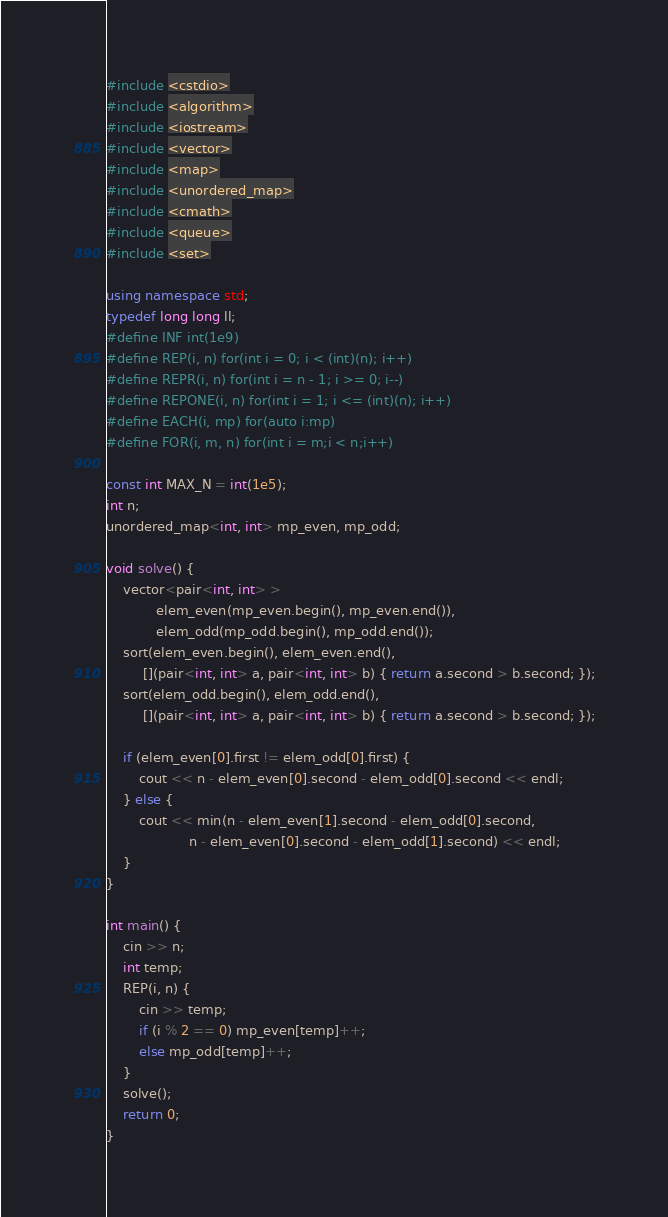<code> <loc_0><loc_0><loc_500><loc_500><_C++_>#include <cstdio>
#include <algorithm>
#include <iostream>
#include <vector>
#include <map>
#include <unordered_map>
#include <cmath>
#include <queue>
#include <set>

using namespace std;
typedef long long ll;
#define INF int(1e9)
#define REP(i, n) for(int i = 0; i < (int)(n); i++)
#define REPR(i, n) for(int i = n - 1; i >= 0; i--)
#define REPONE(i, n) for(int i = 1; i <= (int)(n); i++)
#define EACH(i, mp) for(auto i:mp)
#define FOR(i, m, n) for(int i = m;i < n;i++)

const int MAX_N = int(1e5);
int n;
unordered_map<int, int> mp_even, mp_odd;

void solve() {
    vector<pair<int, int> >
            elem_even(mp_even.begin(), mp_even.end()),
            elem_odd(mp_odd.begin(), mp_odd.end());
    sort(elem_even.begin(), elem_even.end(),
         [](pair<int, int> a, pair<int, int> b) { return a.second > b.second; });
    sort(elem_odd.begin(), elem_odd.end(),
         [](pair<int, int> a, pair<int, int> b) { return a.second > b.second; });

    if (elem_even[0].first != elem_odd[0].first) {
        cout << n - elem_even[0].second - elem_odd[0].second << endl;
    } else {
        cout << min(n - elem_even[1].second - elem_odd[0].second,
                    n - elem_even[0].second - elem_odd[1].second) << endl;
    }
}

int main() {
    cin >> n;
    int temp;
    REP(i, n) {
        cin >> temp;
        if (i % 2 == 0) mp_even[temp]++;
        else mp_odd[temp]++;
    }
    solve();
    return 0;
}</code> 